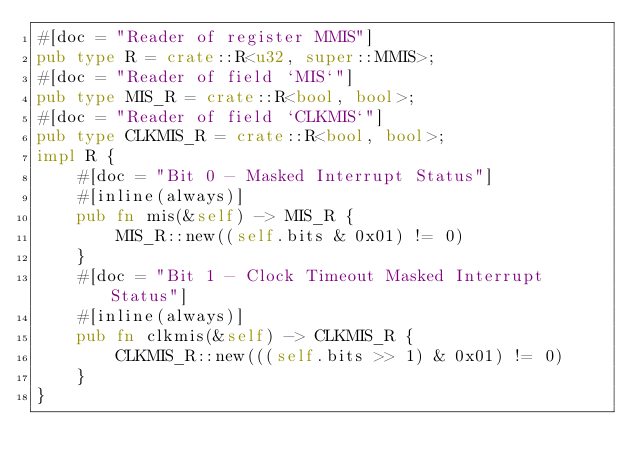Convert code to text. <code><loc_0><loc_0><loc_500><loc_500><_Rust_>#[doc = "Reader of register MMIS"]
pub type R = crate::R<u32, super::MMIS>;
#[doc = "Reader of field `MIS`"]
pub type MIS_R = crate::R<bool, bool>;
#[doc = "Reader of field `CLKMIS`"]
pub type CLKMIS_R = crate::R<bool, bool>;
impl R {
    #[doc = "Bit 0 - Masked Interrupt Status"]
    #[inline(always)]
    pub fn mis(&self) -> MIS_R {
        MIS_R::new((self.bits & 0x01) != 0)
    }
    #[doc = "Bit 1 - Clock Timeout Masked Interrupt Status"]
    #[inline(always)]
    pub fn clkmis(&self) -> CLKMIS_R {
        CLKMIS_R::new(((self.bits >> 1) & 0x01) != 0)
    }
}
</code> 